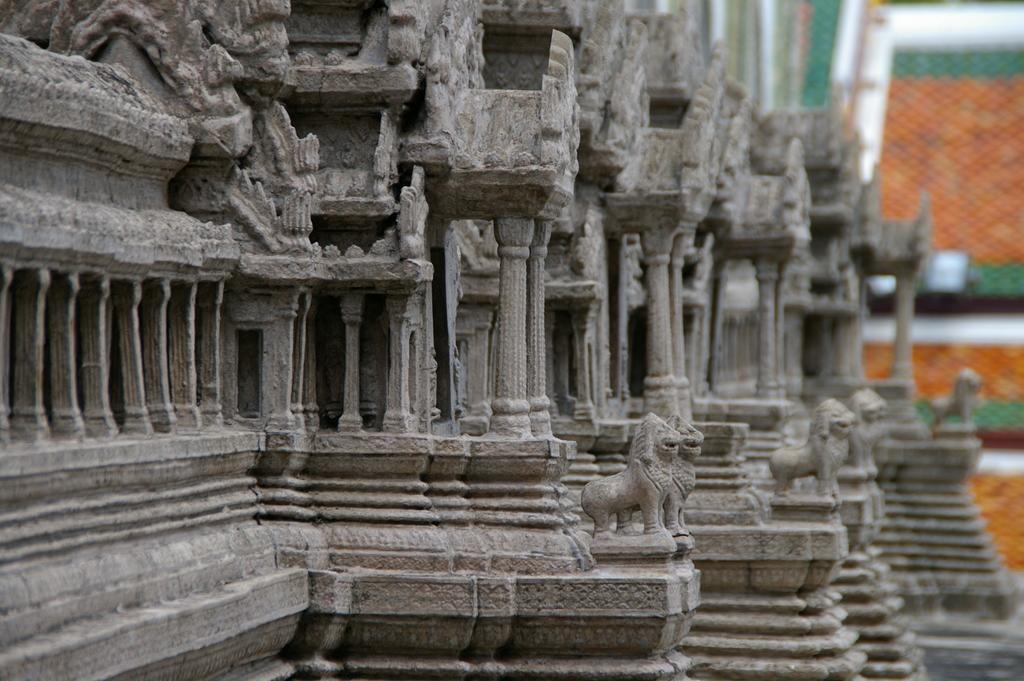What is the main structure in the image? There is a building in the image. What color is the building? The building is gray in color. What colors can be seen in the background of the image? The background of the image includes green and orange colors. Where is the key located in the image? There is no key present in the image. What type of scene is depicted in the image? The image does not depict a specific scene; it simply shows a gray building with a green and orange background. 